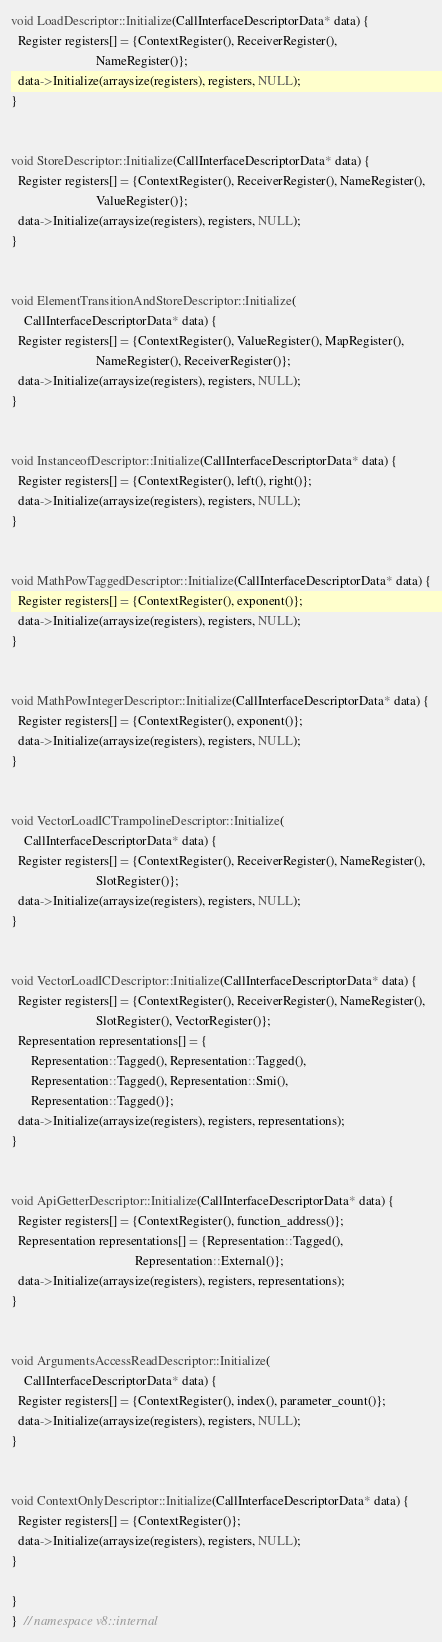<code> <loc_0><loc_0><loc_500><loc_500><_C++_>
void LoadDescriptor::Initialize(CallInterfaceDescriptorData* data) {
  Register registers[] = {ContextRegister(), ReceiverRegister(),
                          NameRegister()};
  data->Initialize(arraysize(registers), registers, NULL);
}


void StoreDescriptor::Initialize(CallInterfaceDescriptorData* data) {
  Register registers[] = {ContextRegister(), ReceiverRegister(), NameRegister(),
                          ValueRegister()};
  data->Initialize(arraysize(registers), registers, NULL);
}


void ElementTransitionAndStoreDescriptor::Initialize(
    CallInterfaceDescriptorData* data) {
  Register registers[] = {ContextRegister(), ValueRegister(), MapRegister(),
                          NameRegister(), ReceiverRegister()};
  data->Initialize(arraysize(registers), registers, NULL);
}


void InstanceofDescriptor::Initialize(CallInterfaceDescriptorData* data) {
  Register registers[] = {ContextRegister(), left(), right()};
  data->Initialize(arraysize(registers), registers, NULL);
}


void MathPowTaggedDescriptor::Initialize(CallInterfaceDescriptorData* data) {
  Register registers[] = {ContextRegister(), exponent()};
  data->Initialize(arraysize(registers), registers, NULL);
}


void MathPowIntegerDescriptor::Initialize(CallInterfaceDescriptorData* data) {
  Register registers[] = {ContextRegister(), exponent()};
  data->Initialize(arraysize(registers), registers, NULL);
}


void VectorLoadICTrampolineDescriptor::Initialize(
    CallInterfaceDescriptorData* data) {
  Register registers[] = {ContextRegister(), ReceiverRegister(), NameRegister(),
                          SlotRegister()};
  data->Initialize(arraysize(registers), registers, NULL);
}


void VectorLoadICDescriptor::Initialize(CallInterfaceDescriptorData* data) {
  Register registers[] = {ContextRegister(), ReceiverRegister(), NameRegister(),
                          SlotRegister(), VectorRegister()};
  Representation representations[] = {
      Representation::Tagged(), Representation::Tagged(),
      Representation::Tagged(), Representation::Smi(),
      Representation::Tagged()};
  data->Initialize(arraysize(registers), registers, representations);
}


void ApiGetterDescriptor::Initialize(CallInterfaceDescriptorData* data) {
  Register registers[] = {ContextRegister(), function_address()};
  Representation representations[] = {Representation::Tagged(),
                                      Representation::External()};
  data->Initialize(arraysize(registers), registers, representations);
}


void ArgumentsAccessReadDescriptor::Initialize(
    CallInterfaceDescriptorData* data) {
  Register registers[] = {ContextRegister(), index(), parameter_count()};
  data->Initialize(arraysize(registers), registers, NULL);
}


void ContextOnlyDescriptor::Initialize(CallInterfaceDescriptorData* data) {
  Register registers[] = {ContextRegister()};
  data->Initialize(arraysize(registers), registers, NULL);
}

}
}  // namespace v8::internal
</code> 